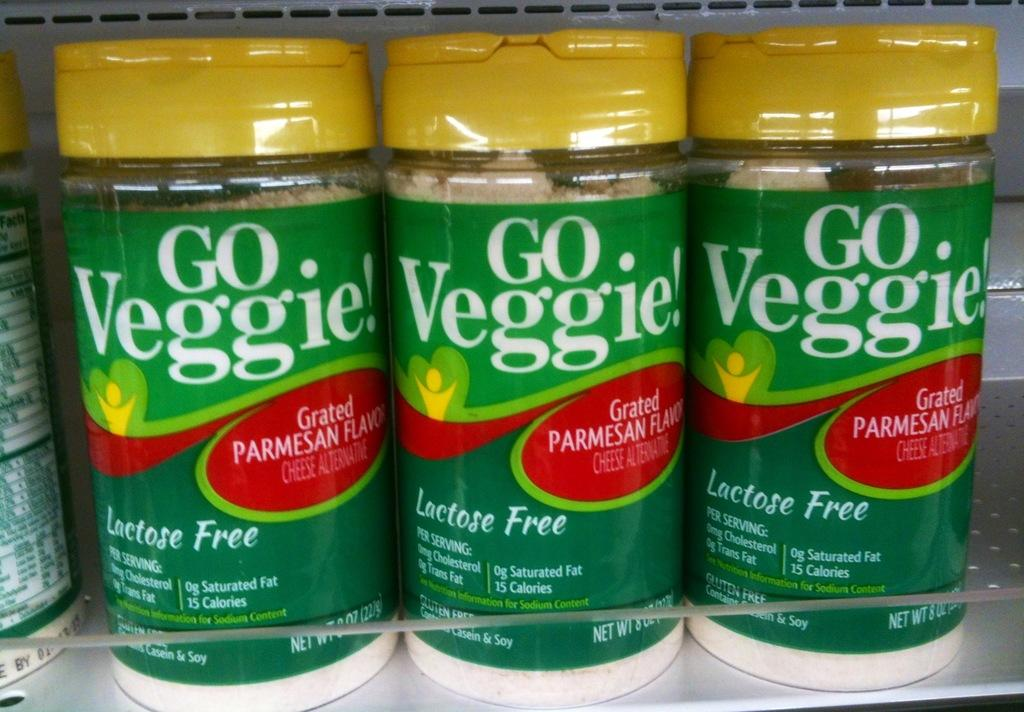Provide a one-sentence caption for the provided image. A lactose free parmesan cheese made from veggies. 